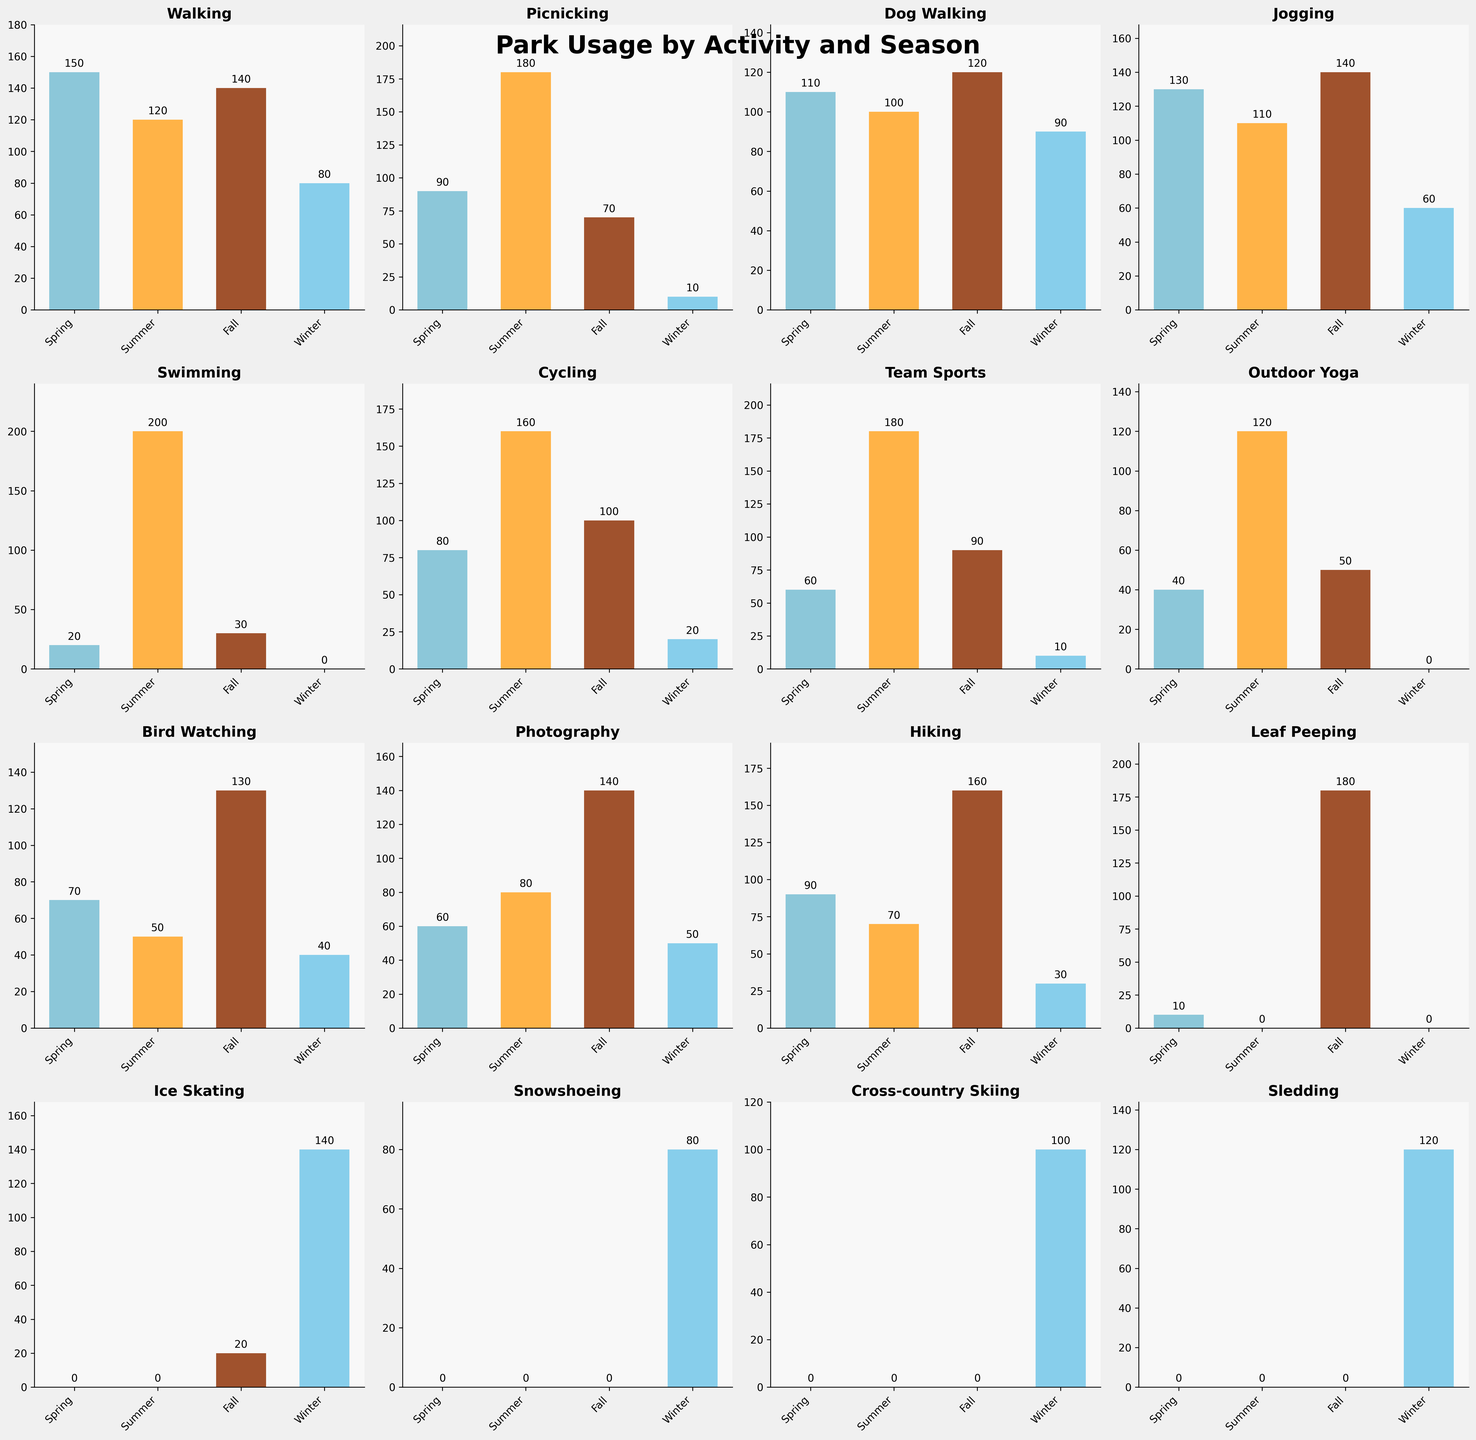What season has the highest usage for Picnicking? The subplot for Picnicking shows the highest bar representing the number of people engaged in that activity. The highest bar is in the Summer category.
Answer: Summer Which activity has the highest participation in Winter? By looking at the subplots for Winter bars, Ice Skating has the highest value, represented by the tallest Winter bar across all activities.
Answer: Ice Skating What is the total number of people participating in Jogging across all seasons? Sum the values from the Jogging subplot for each season: Spring (130) + Summer (110) + Fall (140) + Winter (60).
Answer: 440 Is Hiking more popular in Fall compared to Spring? In the Hiking subplot, compare the height of the Fall bar (160) to the Spring bar (90). The Fall bar is taller.
Answer: Yes In which season is Team Sports least popular? In the Team Sports subplot, the smallest bar corresponds to Winter.
Answer: Winter What’s the most participated activity during the Summer? By checking all activities’ Summer columns, Swimming has the highest bar in Summer.
Answer: Swimming Which activity shows a trend where the participation is lowest in Winter? Examine subplots to find an activity where the Winter bar is the lowest among the four seasons. Activities like Picnicking, Outdoor Yoga, Cycling, and Team Sports clearly have the lowest values in Winter, but let's choose Picnicking for being exceptionally lower.
Answer: Picnicking How many activities have peak participation in Summer? Check each subplot to count how many have their highest bar in Summer: Walking, Picnicking, Jogging, Swimming, Cycling, Team Sports, and Outdoor Yoga.
Answer: 7 Compare Fall Bird Watching to Spring Bird Watching. Which season has a higher participation? Look at the Bird Watching subplot, compare the Fall (130) bar to the Spring (70) bar. The Fall bar is higher.
Answer: Fall How does Winter Sledding participation compare to Winter Ice Skating participation? In the Winter column for both Sledding and Ice Skating subplots, Ice Skating (140) has a taller bar than Sledding (120).
Answer: Ice Skating is higher 